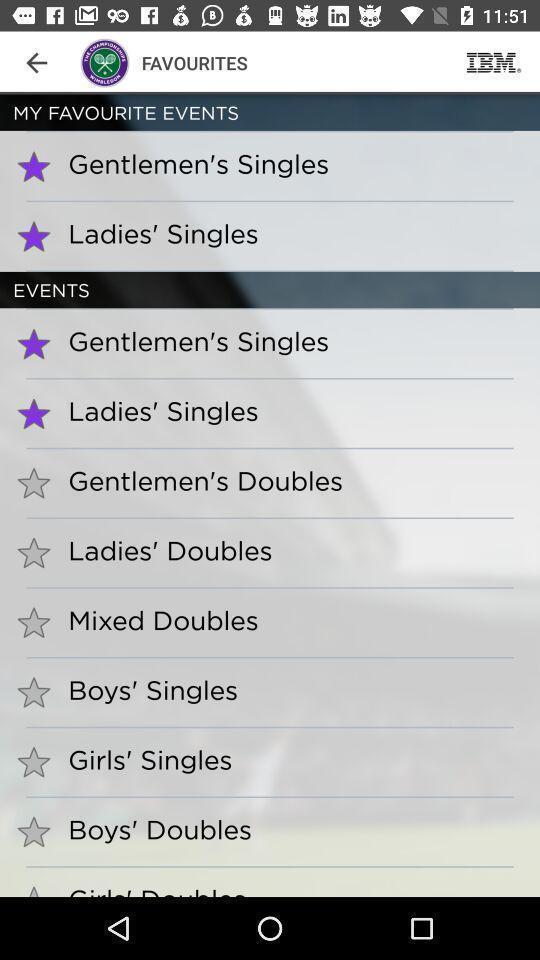Please provide a description for this image. Screen shows favourites with list of options. 